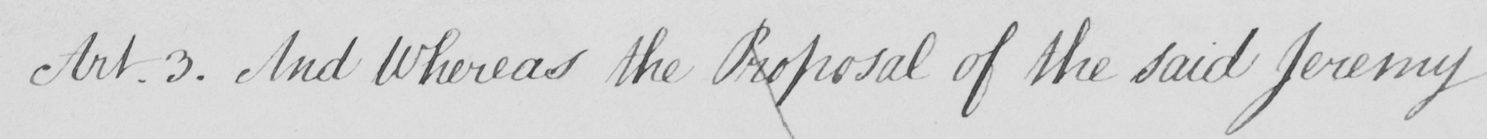Please transcribe the handwritten text in this image. Art.3 . And Whereas the Proposal of the said Jeremy 